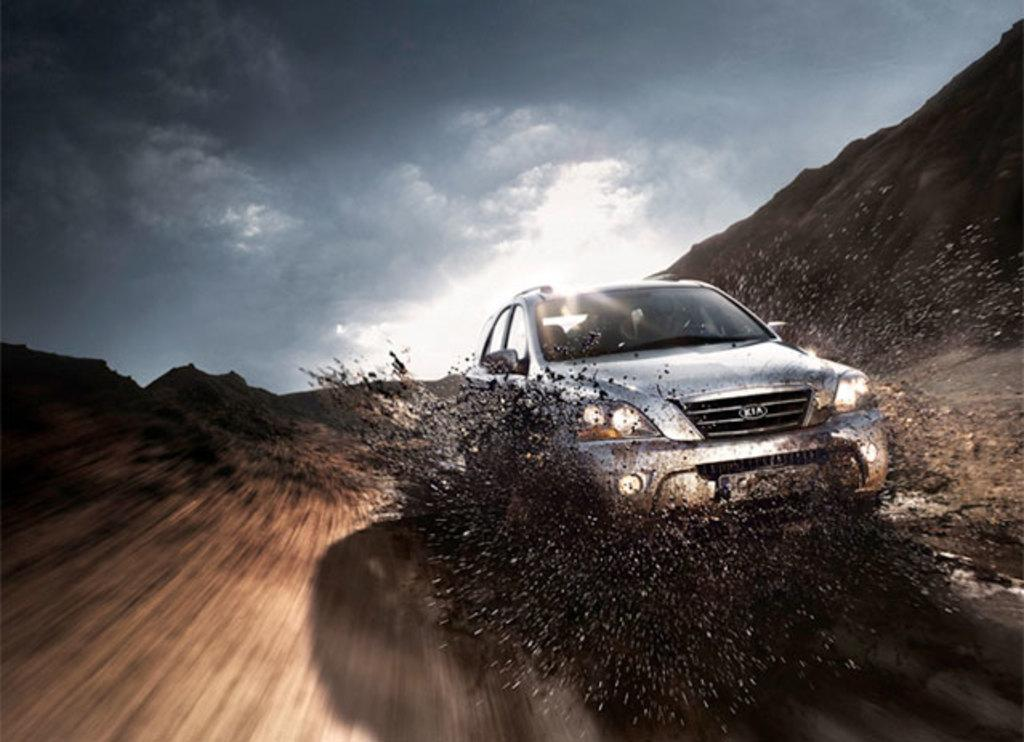What is the main subject of the image? There is a car in the image. What type of terrain is visible at the bottom of the image? There is sand at the bottom of the image, which suggests a desert setting. What can be seen in the sky in the image? The sky is visible at the top of the image. Where is the tramp located in the image? There is no tramp present in the image. What type of mark can be seen on the car's hood in the image? There is no mention of any mark on the car's hood in the provided facts, so it cannot be determined from the image. 